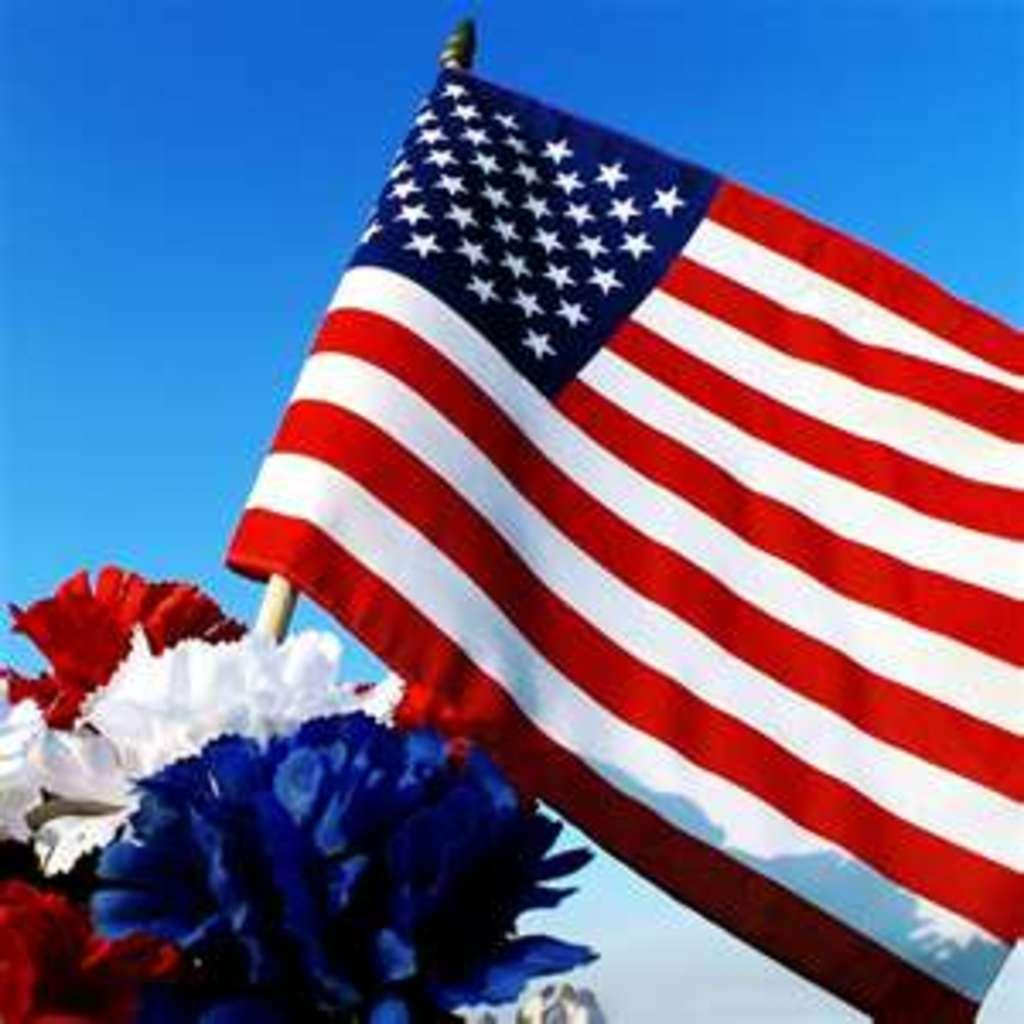What is the main object in the image? There is a flag in the image. What other elements can be seen in the image? There are flowers in the image. What can be seen in the background of the image? The sky is visible in the background of the image. How many girls are pushing the cart in the image? There is no cart or girls present in the image. What type of beetle can be seen crawling on the flowers in the image? There are no beetles visible in the image; only the flag and flowers are present. 